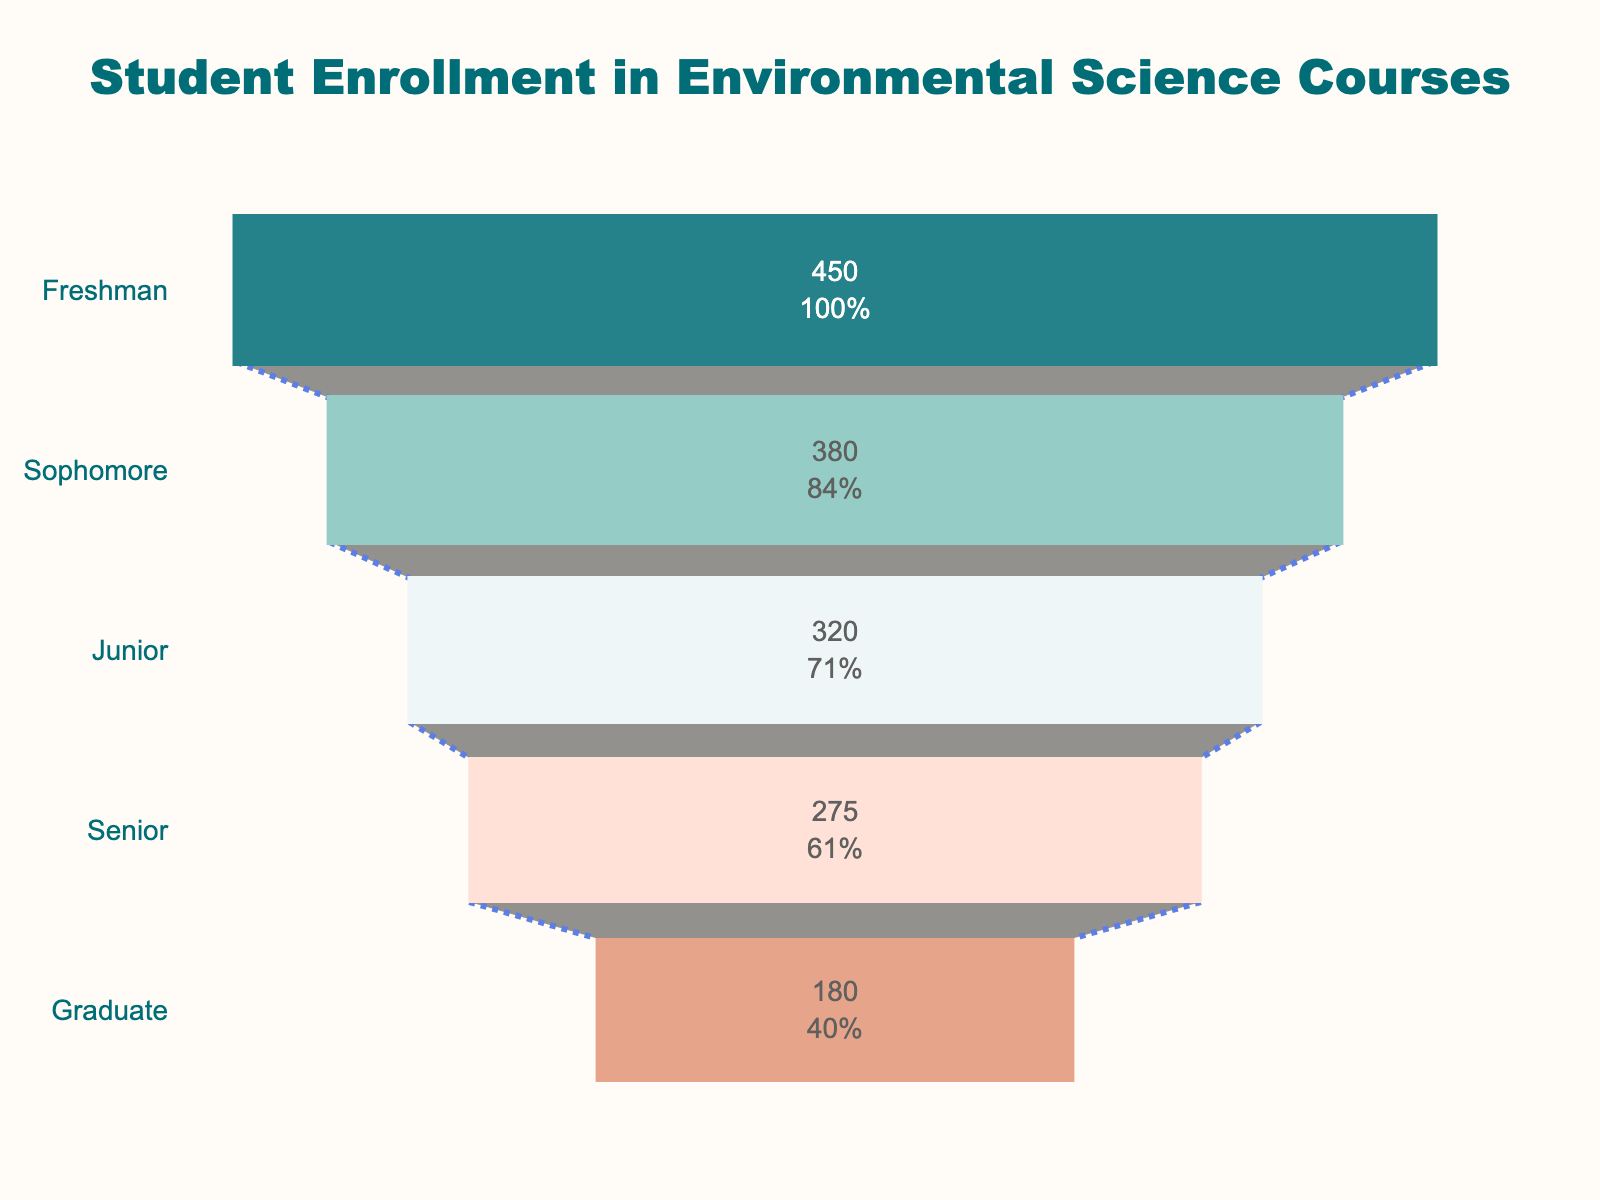How many graduate students are enrolled in environmental science courses? The funnel chart shows the number of students enrolled for each year level, including the graduate level. By looking at the chart, we see that the number of graduate students is 180.
Answer: 180 What is the total student enrollment across all year levels? To calculate the total enrollment, add the number of students at every year level: 450 (Freshman) + 380 (Sophomore) + 320 (Junior) + 275 (Senior) + 180 (Graduate) = 1605 students.
Answer: 1605 Which year level has the highest number of students enrolled in environmental science courses? The funnel chart shows the number of students for each year level. The Freshman year has the highest number with 450 students.
Answer: Freshman By what percentage does enrollment drop from Freshman to Sophomore year? To find the percentage drop, use the following calculation: ((450 - 380) / 450) * 100%. This gives: (70 / 450) * 100% = 15.56%.
Answer: 15.56% How does the enrollment for Seniors compare with that for Juniors? From the funnel chart, Juniors have 320 students and Seniors have 275 students. The difference is 320 - 275 = 45 students, meaning enrollment drops by 45 from Junior to Senior year.
Answer: 45 fewer Which year levels have fewer than 300 students? Observing the funnel chart, the Senior and Graduate year levels have fewer than 300 students, with 275 and 180 students respectively.
Answer: Senior, Graduate What is the average enrollment per year level? To find the average enrollment: Calculate the total enrollment (1605 students) and then divide by the number of year levels (5). So, 1605 / 5 = 321 students.
Answer: 321 What percentage of students are Seniors out of the total enrollment? Using total enrollment (1605), calculate the percentage of Seniors: (275 / 1605) * 100%, which equals approximately 17.14%.
Answer: 17.14% Compare the enrollments of Underclassmen (Freshmen, Sophomores) and Upperclassmen (Juniors, Seniors). Which group has more students? Calculate the sum for Underclassmen (450 + 380 = 830) and Upperclassmen (320 + 275 = 595). Comparing these, Underclassmen have more students.
Answer: Underclassmen What is the percentage decrease in student enrollment from Freshman to Graduate level? Calculate the initial-to-final percentage decrease: ((450 - 180) / 450) * 100%, resulting in ((270) / 450) * 100% = 60%.
Answer: 60% 